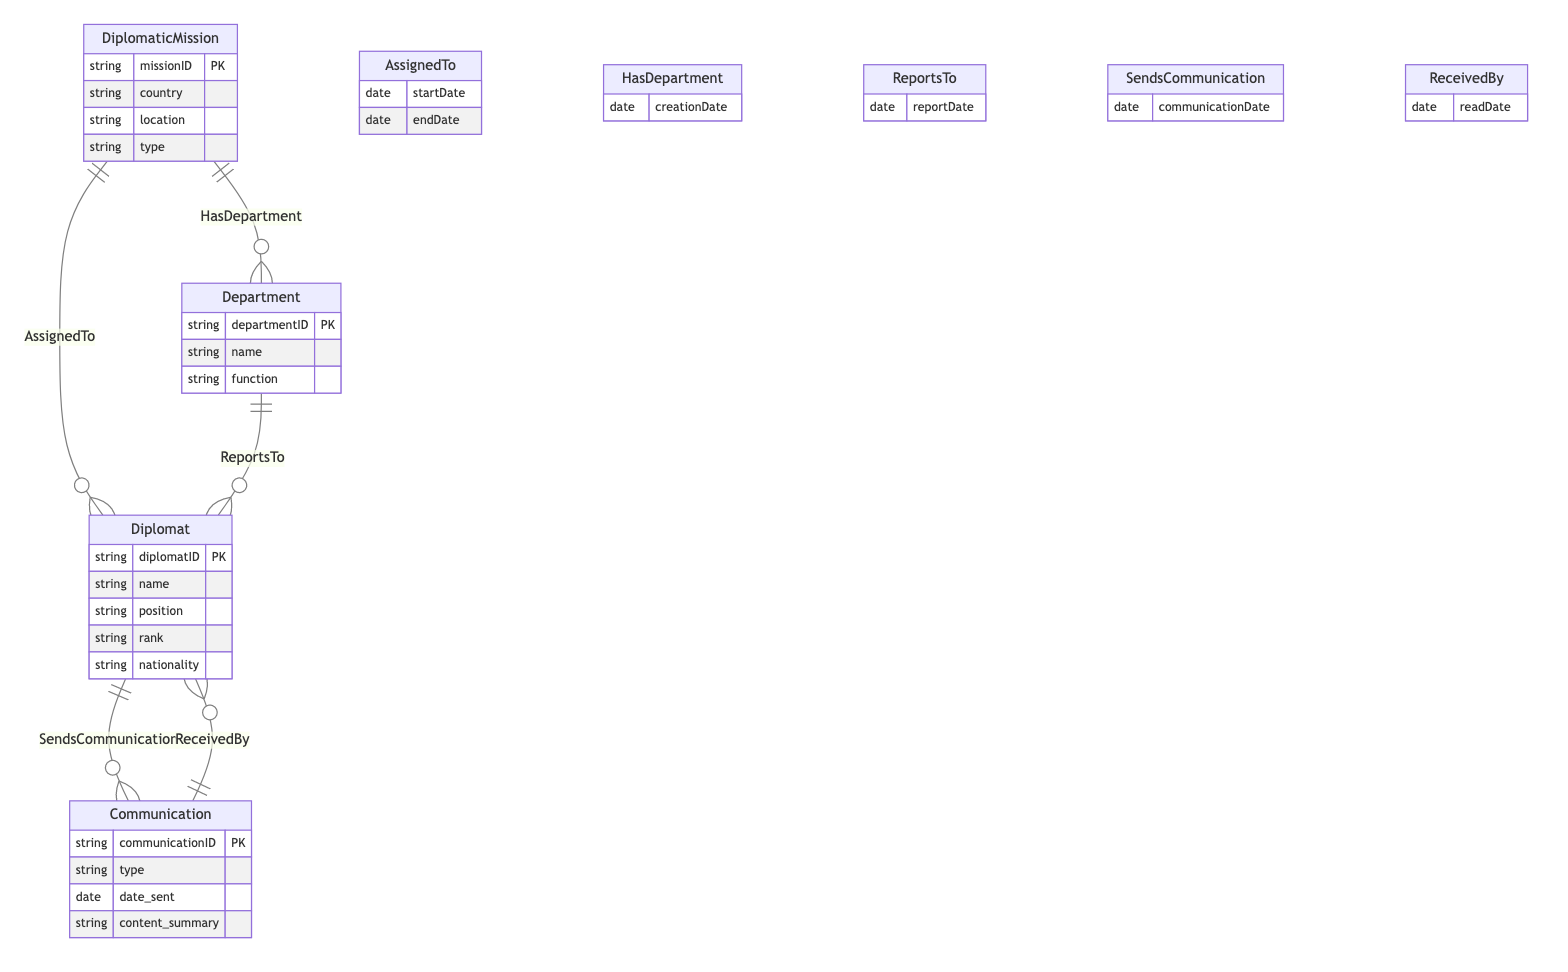What entities are represented in the diagram? The diagram represents four entities: DiplomaticMission, Diplomat, Department, and Communication. Each entity includes its attributes, providing essential information for understanding the relationships and data flow.
Answer: DiplomaticMission, Diplomat, Department, Communication How many attributes does the Diplomat entity have? The Diplomat entity contains five attributes: diplomatID, name, position, rank, and nationality. Counting these attributes gives a total of five.
Answer: five What relationship connects Department and Diplomat? The relationship that connects Department and Diplomat is called "ReportsTo." This relationship indicates that a diplomat reports to a department within the diplomatic mission.
Answer: ReportsTo What is the primary key of the Communication entity? The primary key of the Communication entity is communicationID. It uniquely identifies each communication record within the diagram.
Answer: communicationID How many relationships are depicted in the diagram? The diagram depicts five relationships: AssignedTo, HasDepartment, ReportsTo, SendsCommunication, and ReceivedBy. Counting these will show the total relationships involved.
Answer: five Which entity has a one-to-many relationship with the DiplomaticMission entity? The Diplomat entity has a one-to-many relationship with the DiplomaticMission entity through the "AssignedTo" relationship, indicating multiple diplomats can be assigned to a single diplomatic mission.
Answer: Diplomat What attribute is common to both the SendsCommunication and ReceivedBy relationships? The "communicationDate" attribute is common to both the SendsCommunication and ReceivedBy relationships, indicating when communication occurs and when it is read.
Answer: communicationDate Which attribute in the HasDepartment relationship indicates when the department was created? The attribute "creationDate" in the HasDepartment relationship indicates the date on which the department was created under the diplomatic mission.
Answer: creationDate Which entity can send and receive communications according to the diagram? The Diplomat entity can send and receive communications as identified in the "SendsCommunication" and "ReceivedBy" relationships, signifying diplomats' role in communications.
Answer: Diplomat 